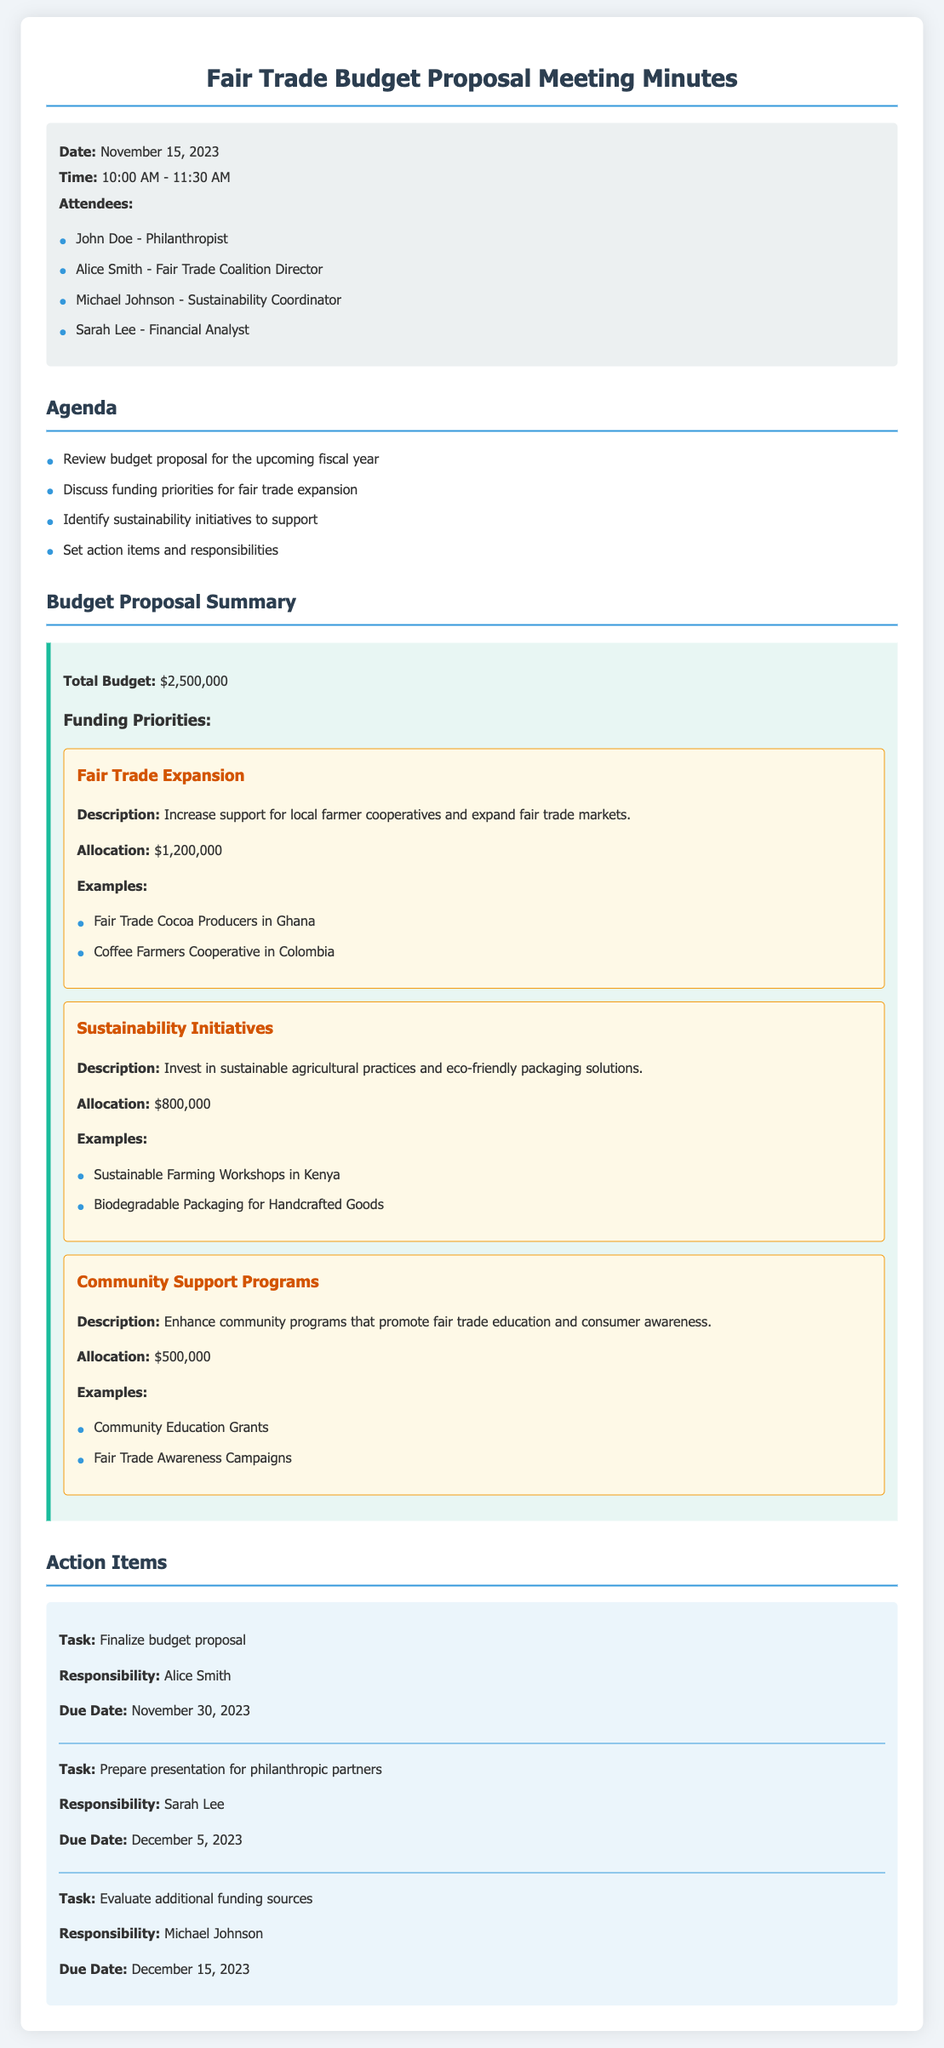What is the date of the meeting? The date of the meeting is specified in the meta-info section of the document.
Answer: November 15, 2023 How much is allocated for Fair Trade Expansion? The allocation for Fair Trade Expansion is detailed under funding priorities in the budget proposal summary.
Answer: $1,200,000 Who is responsible for finalizing the budget proposal? The responsibility for finalizing the budget proposal is outlined in the action items section of the document.
Answer: Alice Smith What is the total budget for the fiscal year? The total budget is mentioned at the beginning of the budget proposal summary.
Answer: $2,500,000 What are two examples of sustainability initiatives? The examples of sustainability initiatives are listed in the funding priorities section of the document.
Answer: Sustainable Farming Workshops in Kenya, Biodegradable Packaging for Handcrafted Goods What is the due date for the presentation to philanthropic partners? The due date for the presentation is specified in the action items section of the document.
Answer: December 5, 2023 How much is allocated for Community Support Programs? The allocation for Community Support Programs is stated in the budget proposal summary.
Answer: $500,000 What is the task assigned to Michael Johnson? Michael Johnson's task is mentioned in the action items section of the document.
Answer: Evaluate additional funding sources 